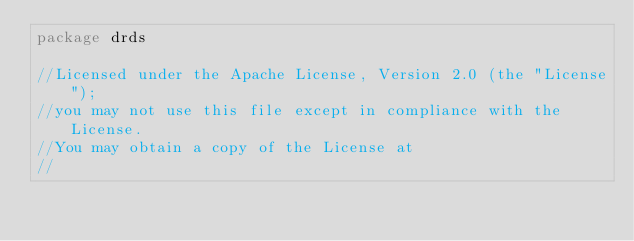Convert code to text. <code><loc_0><loc_0><loc_500><loc_500><_Go_>package drds

//Licensed under the Apache License, Version 2.0 (the "License");
//you may not use this file except in compliance with the License.
//You may obtain a copy of the License at
//</code> 